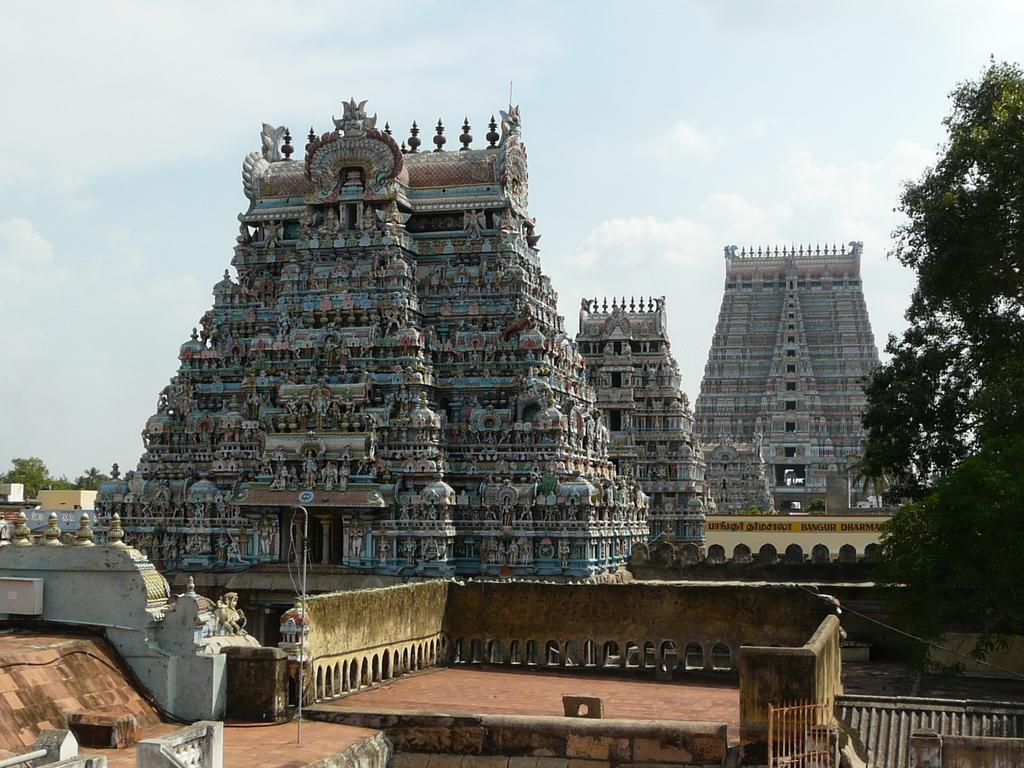What type of structures can be seen in the image? There are temples in the image. What other natural elements are present in the image? There are trees in the image. What type of barrier can be seen in the image? There is an iron grill in the image. What other man-made structures are visible in the image? There are buildings in the image. What is visible in the background of the image? The sky is visible in the image, and there are clouds in the sky. How does the street look like in the image? There is no street present in the image; it features temples, trees, an iron grill, buildings, and a sky with clouds. What type of emotion can be seen on the clouds in the image? Clouds do not have emotions; they are inanimate objects. 